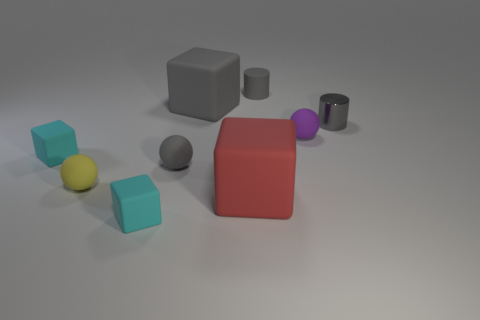Add 1 tiny brown matte spheres. How many objects exist? 10 Subtract all red blocks. How many blocks are left? 3 Subtract 4 cubes. How many cubes are left? 0 Subtract all gray spheres. How many spheres are left? 2 Subtract all cylinders. How many objects are left? 7 Subtract all metallic things. Subtract all big red blocks. How many objects are left? 7 Add 1 yellow rubber balls. How many yellow rubber balls are left? 2 Add 2 tiny purple matte balls. How many tiny purple matte balls exist? 3 Subtract 1 purple spheres. How many objects are left? 8 Subtract all yellow blocks. Subtract all green balls. How many blocks are left? 4 